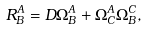Convert formula to latex. <formula><loc_0><loc_0><loc_500><loc_500>R _ { B } ^ { A } = D \Omega _ { B } ^ { A } + \Omega _ { C } ^ { A } \Omega _ { B } ^ { C } ,</formula> 